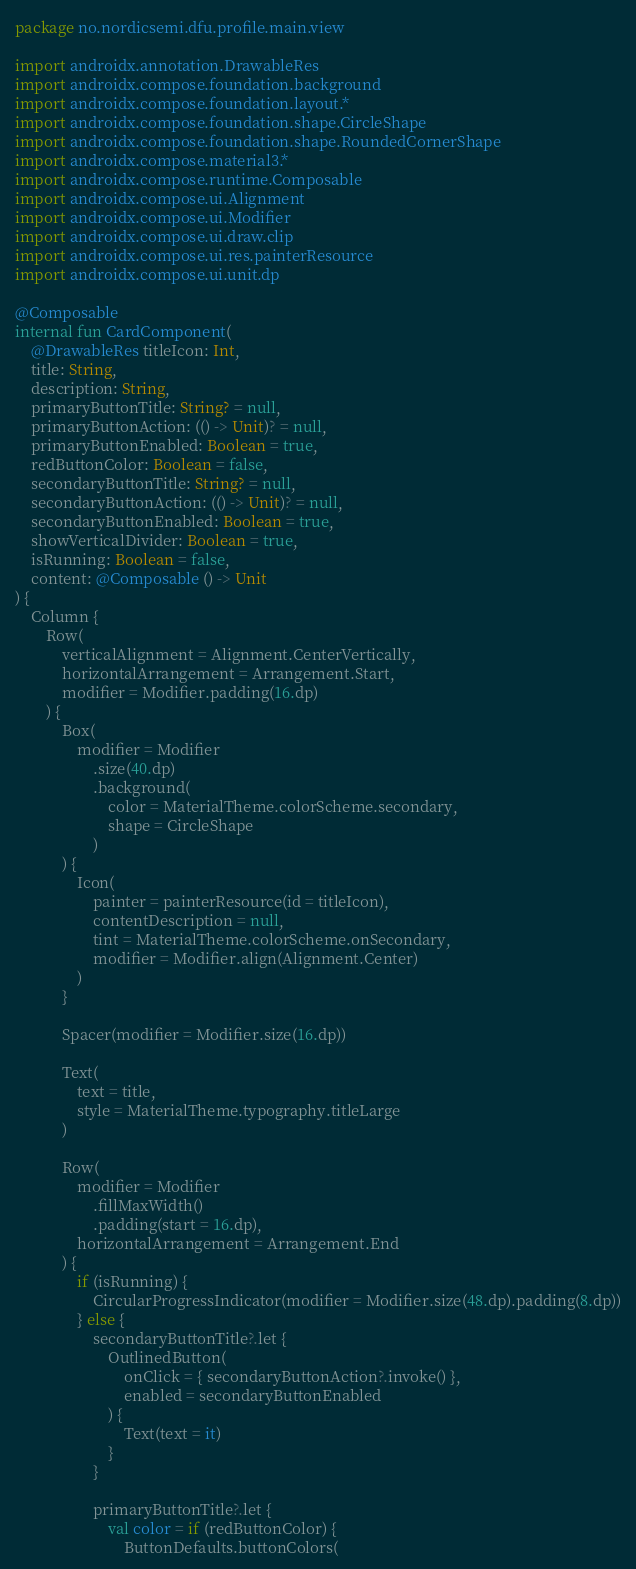Convert code to text. <code><loc_0><loc_0><loc_500><loc_500><_Kotlin_>package no.nordicsemi.dfu.profile.main.view

import androidx.annotation.DrawableRes
import androidx.compose.foundation.background
import androidx.compose.foundation.layout.*
import androidx.compose.foundation.shape.CircleShape
import androidx.compose.foundation.shape.RoundedCornerShape
import androidx.compose.material3.*
import androidx.compose.runtime.Composable
import androidx.compose.ui.Alignment
import androidx.compose.ui.Modifier
import androidx.compose.ui.draw.clip
import androidx.compose.ui.res.painterResource
import androidx.compose.ui.unit.dp

@Composable
internal fun CardComponent(
    @DrawableRes titleIcon: Int,
    title: String,
    description: String,
    primaryButtonTitle: String? = null,
    primaryButtonAction: (() -> Unit)? = null,
    primaryButtonEnabled: Boolean = true,
    redButtonColor: Boolean = false,
    secondaryButtonTitle: String? = null,
    secondaryButtonAction: (() -> Unit)? = null,
    secondaryButtonEnabled: Boolean = true,
    showVerticalDivider: Boolean = true,
    isRunning: Boolean = false,
    content: @Composable () -> Unit
) {
    Column {
        Row(
            verticalAlignment = Alignment.CenterVertically,
            horizontalArrangement = Arrangement.Start,
            modifier = Modifier.padding(16.dp)
        ) {
            Box(
                modifier = Modifier
                    .size(40.dp)
                    .background(
                        color = MaterialTheme.colorScheme.secondary,
                        shape = CircleShape
                    )
            ) {
                Icon(
                    painter = painterResource(id = titleIcon),
                    contentDescription = null,
                    tint = MaterialTheme.colorScheme.onSecondary,
                    modifier = Modifier.align(Alignment.Center)
                )
            }

            Spacer(modifier = Modifier.size(16.dp))

            Text(
                text = title,
                style = MaterialTheme.typography.titleLarge
            )

            Row(
                modifier = Modifier
                    .fillMaxWidth()
                    .padding(start = 16.dp),
                horizontalArrangement = Arrangement.End
            ) {
                if (isRunning) {
                    CircularProgressIndicator(modifier = Modifier.size(48.dp).padding(8.dp))
                } else {
                    secondaryButtonTitle?.let {
                        OutlinedButton(
                            onClick = { secondaryButtonAction?.invoke() },
                            enabled = secondaryButtonEnabled
                        ) {
                            Text(text = it)
                        }
                    }

                    primaryButtonTitle?.let {
                        val color = if (redButtonColor) {
                            ButtonDefaults.buttonColors(</code> 